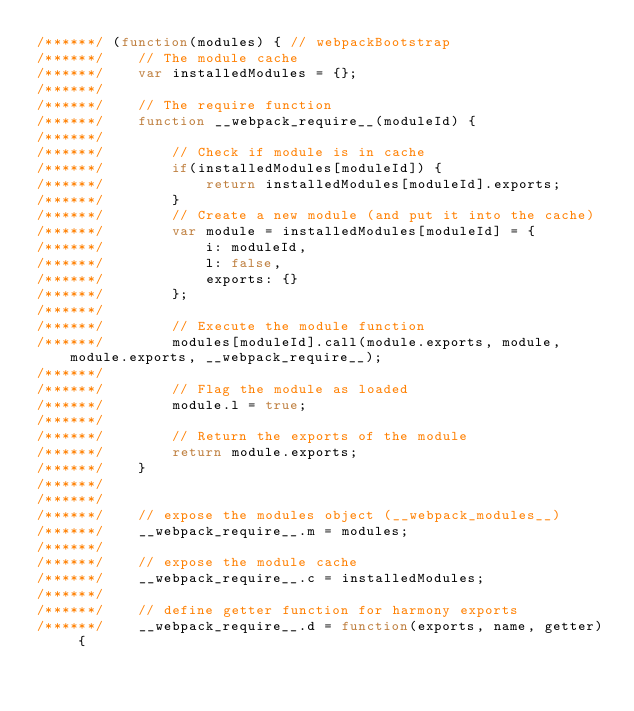<code> <loc_0><loc_0><loc_500><loc_500><_JavaScript_>/******/ (function(modules) { // webpackBootstrap
/******/ 	// The module cache
/******/ 	var installedModules = {};
/******/
/******/ 	// The require function
/******/ 	function __webpack_require__(moduleId) {
/******/
/******/ 		// Check if module is in cache
/******/ 		if(installedModules[moduleId]) {
/******/ 			return installedModules[moduleId].exports;
/******/ 		}
/******/ 		// Create a new module (and put it into the cache)
/******/ 		var module = installedModules[moduleId] = {
/******/ 			i: moduleId,
/******/ 			l: false,
/******/ 			exports: {}
/******/ 		};
/******/
/******/ 		// Execute the module function
/******/ 		modules[moduleId].call(module.exports, module, module.exports, __webpack_require__);
/******/
/******/ 		// Flag the module as loaded
/******/ 		module.l = true;
/******/
/******/ 		// Return the exports of the module
/******/ 		return module.exports;
/******/ 	}
/******/
/******/
/******/ 	// expose the modules object (__webpack_modules__)
/******/ 	__webpack_require__.m = modules;
/******/
/******/ 	// expose the module cache
/******/ 	__webpack_require__.c = installedModules;
/******/
/******/ 	// define getter function for harmony exports
/******/ 	__webpack_require__.d = function(exports, name, getter) {</code> 